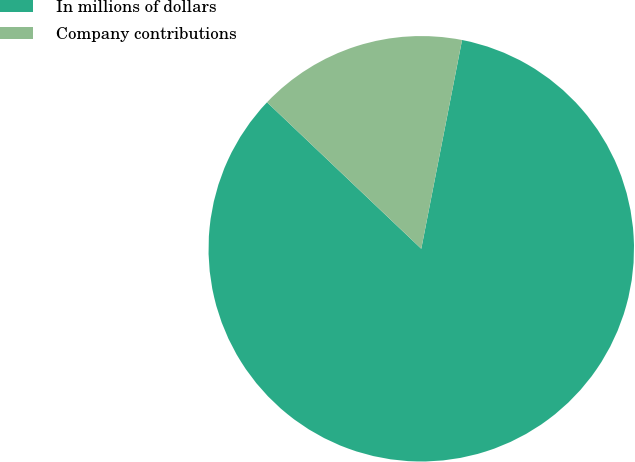Convert chart to OTSL. <chart><loc_0><loc_0><loc_500><loc_500><pie_chart><fcel>In millions of dollars<fcel>Company contributions<nl><fcel>84.02%<fcel>15.98%<nl></chart> 